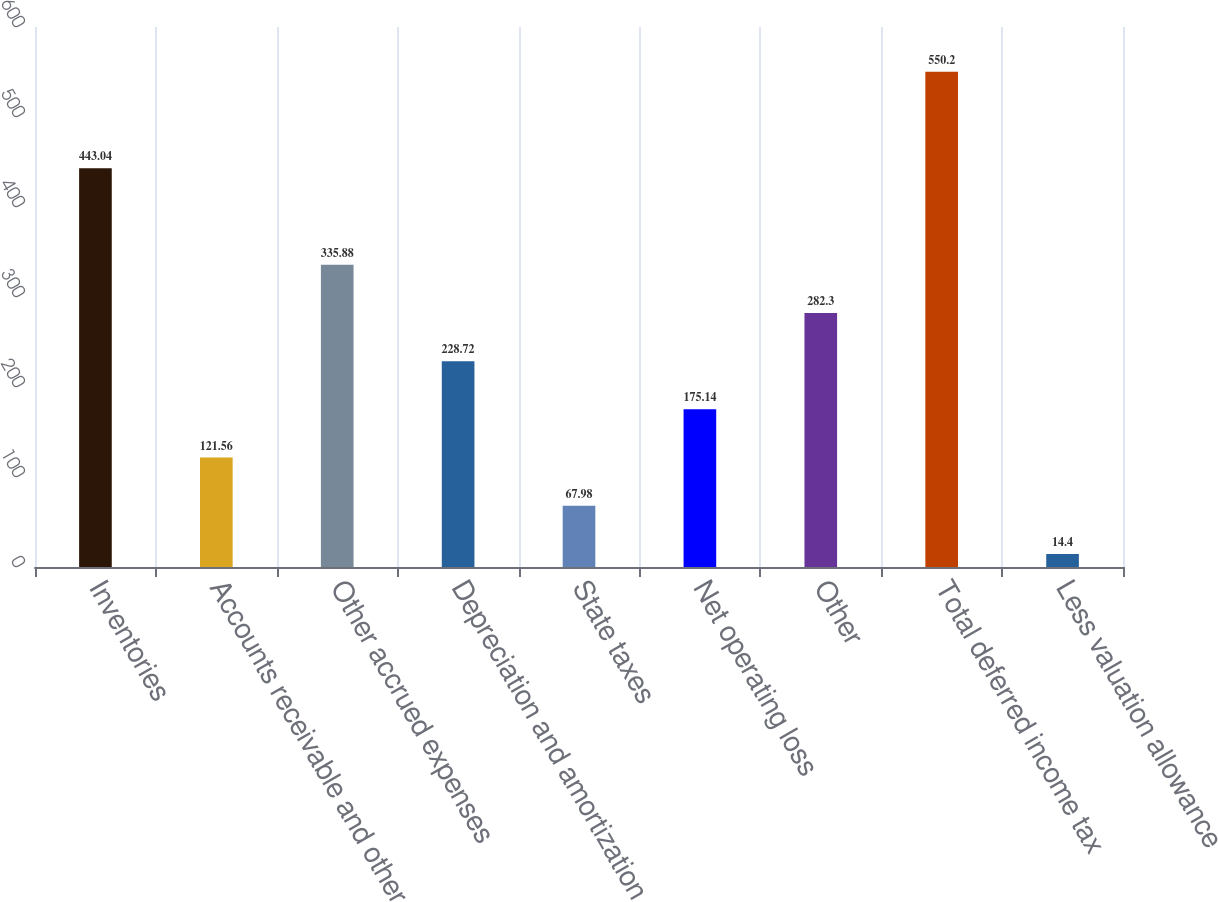Convert chart. <chart><loc_0><loc_0><loc_500><loc_500><bar_chart><fcel>Inventories<fcel>Accounts receivable and other<fcel>Other accrued expenses<fcel>Depreciation and amortization<fcel>State taxes<fcel>Net operating loss<fcel>Other<fcel>Total deferred income tax<fcel>Less valuation allowance<nl><fcel>443.04<fcel>121.56<fcel>335.88<fcel>228.72<fcel>67.98<fcel>175.14<fcel>282.3<fcel>550.2<fcel>14.4<nl></chart> 